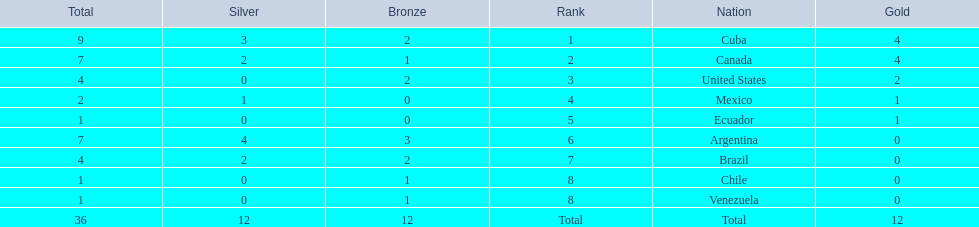What were all of the nations involved in the canoeing at the 2011 pan american games? Cuba, Canada, United States, Mexico, Ecuador, Argentina, Brazil, Chile, Venezuela, Total. Of these, which had a numbered rank? Cuba, Canada, United States, Mexico, Ecuador, Argentina, Brazil, Chile, Venezuela. From these, which had the highest number of bronze? Argentina. 